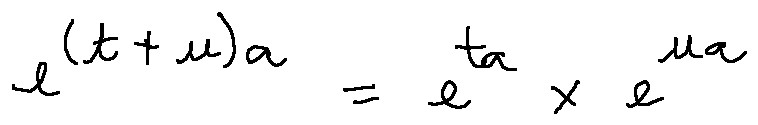Convert formula to latex. <formula><loc_0><loc_0><loc_500><loc_500>e ^ { ( t + u ) a } = e ^ { t a } \times e ^ { u a }</formula> 